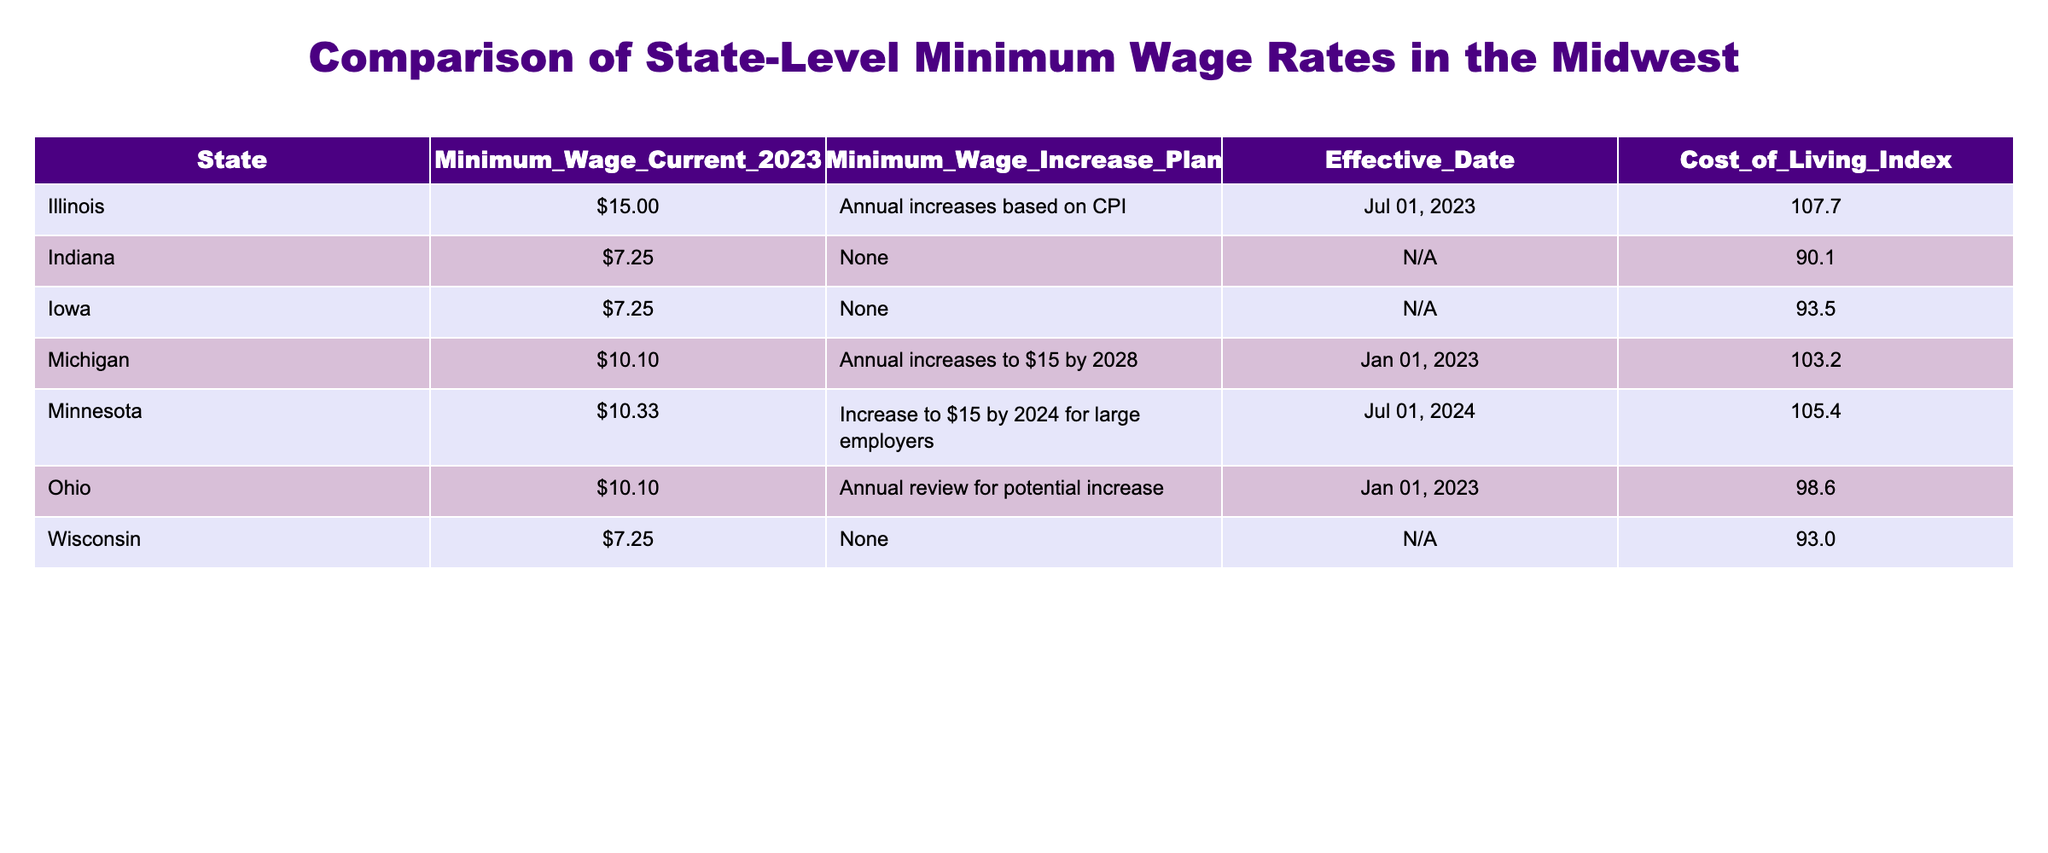What is the minimum wage in Indiana for 2023? According to the table, Indiana has a minimum wage of $7.25 for the year 2023.
Answer: $7.25 Which state has the highest minimum wage in 2023? By reviewing the minimum wage current figures in the table, Illinois has the highest minimum wage at $15.00.
Answer: Illinois Is there a plan for minimum wage increases in Iowa? The table indicates that Iowa currently has no minimum wage increase plan listed, which means there are no planned increases in the near future.
Answer: No What is the effective date for Michigan's minimum wage increase? The table shows that the effective date for Michigan’s minimum wage increase is January 1, 2023.
Answer: January 1, 2023 What is the average minimum wage for the states listed, excluding Indiana and Wisconsin? The minimum wages for Illinois ($15.00), Michigan ($10.10), Minnesota ($10.33), Ohio ($10.10), and Iowa ($7.25) are summed up to $52.78. There are five states considered, leading to an average of $52.78/5 = $10.56.
Answer: $10.56 Which states have a minimum wage lower than the cost of living index of 100? Comparing the minimum wage values and the cost of living indices, Indiana ($7.25), Iowa ($7.25), and Wisconsin ($7.25) all have minimum wages lower than a cost of living index of 100.
Answer: Indiana, Iowa, Wisconsin Is Minnesota planning to increase its minimum wage by 2024? The table indicates that Minnesota has an increase plan to raise the minimum wage to $15 by July 2024 for large employers. Therefore, the answer is yes.
Answer: Yes How much will Michigan's minimum wage increase by 2028? Since Michigan plans to gradually reach $15 by 2028, we calculate the difference from the current $10.10, which leads to a total increase of $15.00 - $10.10 = $4.90 by that date.
Answer: $4.90 Can we say that all states listed have a current minimum wage above $8? Reviewing the minimum wage figures, we find that Indiana, Iowa, and Wisconsin all currently have minimum wages of $7.25, which means not all states have a minimum wage above $8. Therefore, the statement is false.
Answer: No 